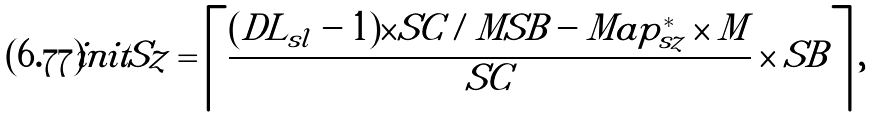Convert formula to latex. <formula><loc_0><loc_0><loc_500><loc_500>i n i t S z = \left \lceil \frac { ( D L _ { s l } - 1 ) \times S C / M S B - M a p _ { s z } ^ { * } \times M } { S C } \times S B \right \rceil ,</formula> 